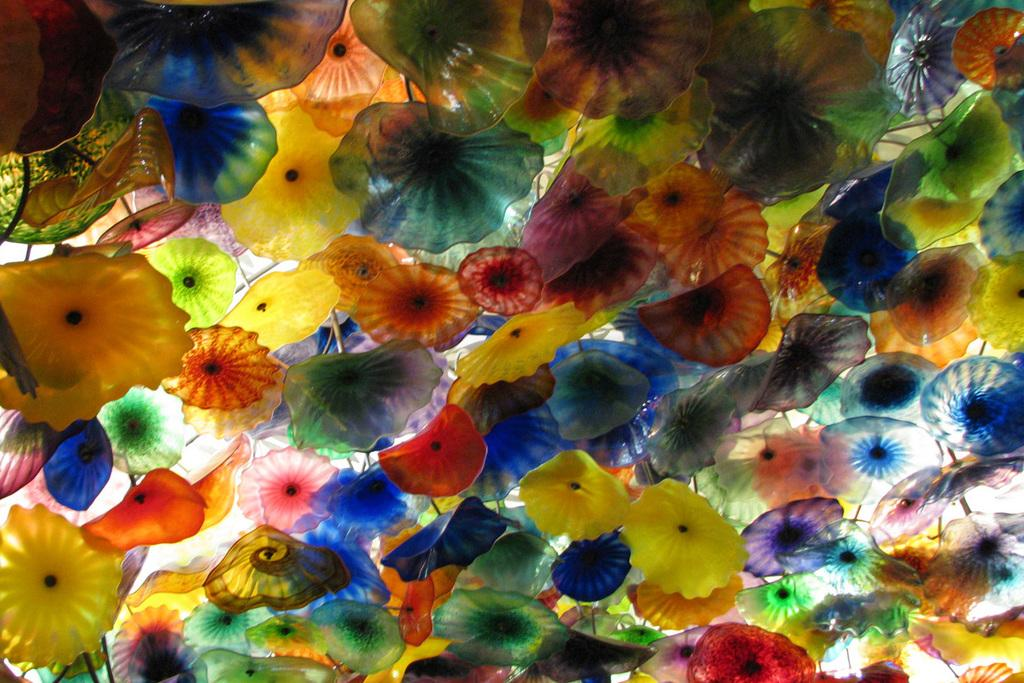What can be observed about the colors of the objects in the image? There are colorful things in the image, and the colors include red, orange, yellow, blue, and green. Can you describe the variety of colors present in the image? The colors present in the image are red, orange, yellow, blue, and green. What type of soda is being served in the image? There is no soda present in the image; it only features colorful objects. 